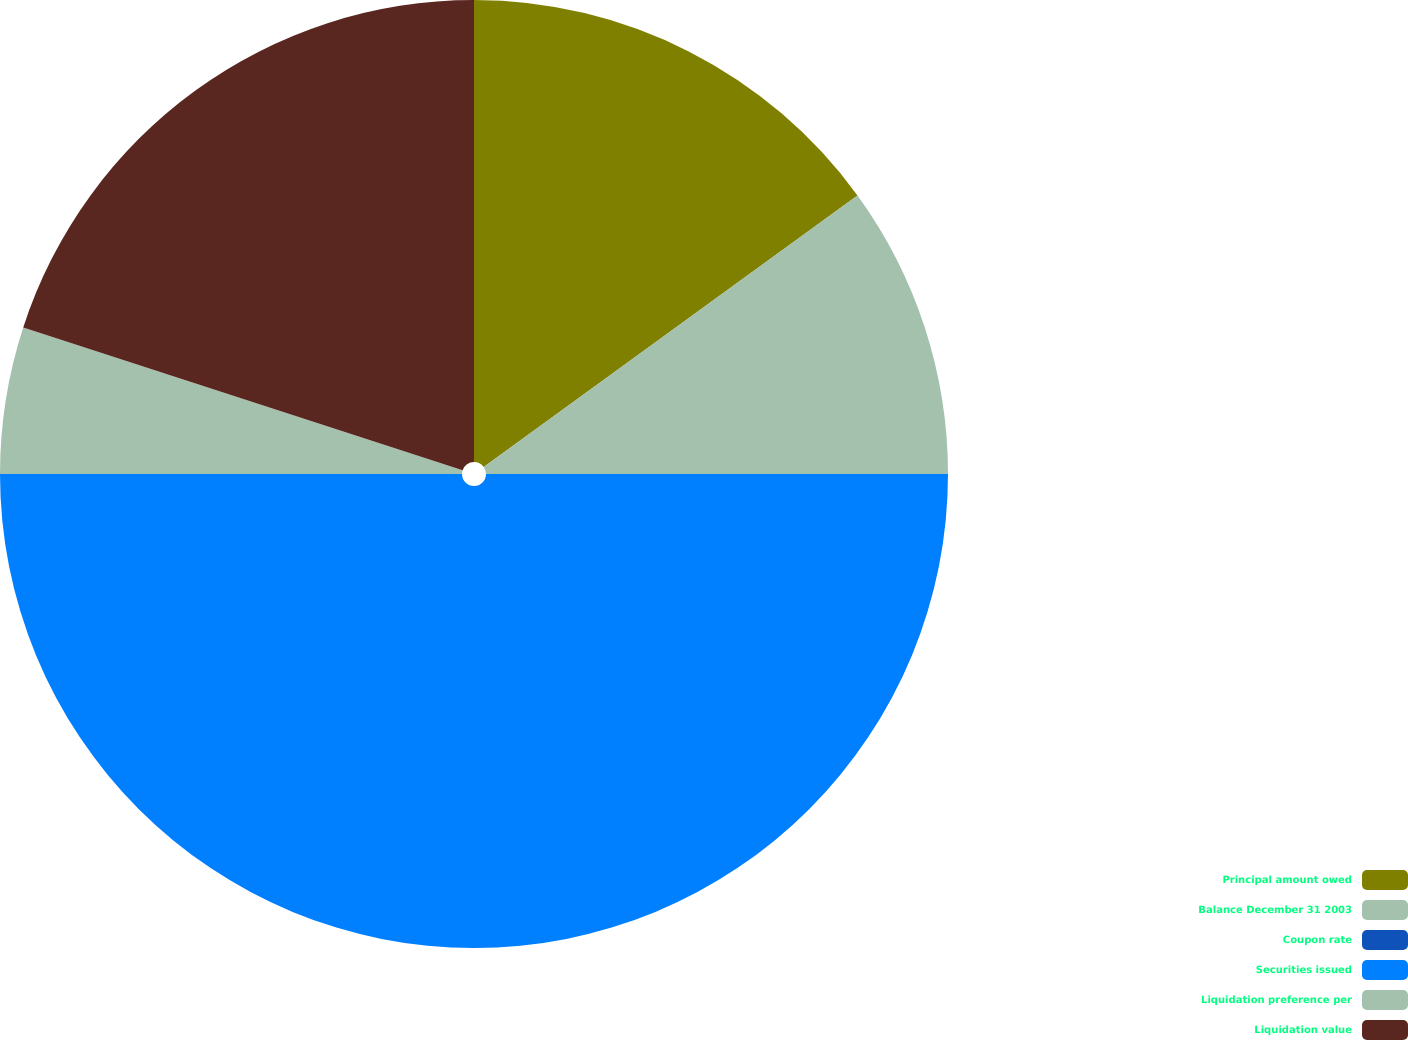<chart> <loc_0><loc_0><loc_500><loc_500><pie_chart><fcel>Principal amount owed<fcel>Balance December 31 2003<fcel>Coupon rate<fcel>Securities issued<fcel>Liquidation preference per<fcel>Liquidation value<nl><fcel>15.0%<fcel>10.0%<fcel>0.0%<fcel>50.0%<fcel>5.0%<fcel>20.0%<nl></chart> 